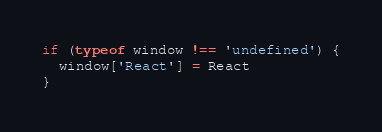<code> <loc_0><loc_0><loc_500><loc_500><_JavaScript_>if (typeof window !== 'undefined') {
  window['React'] = React
}
</code> 